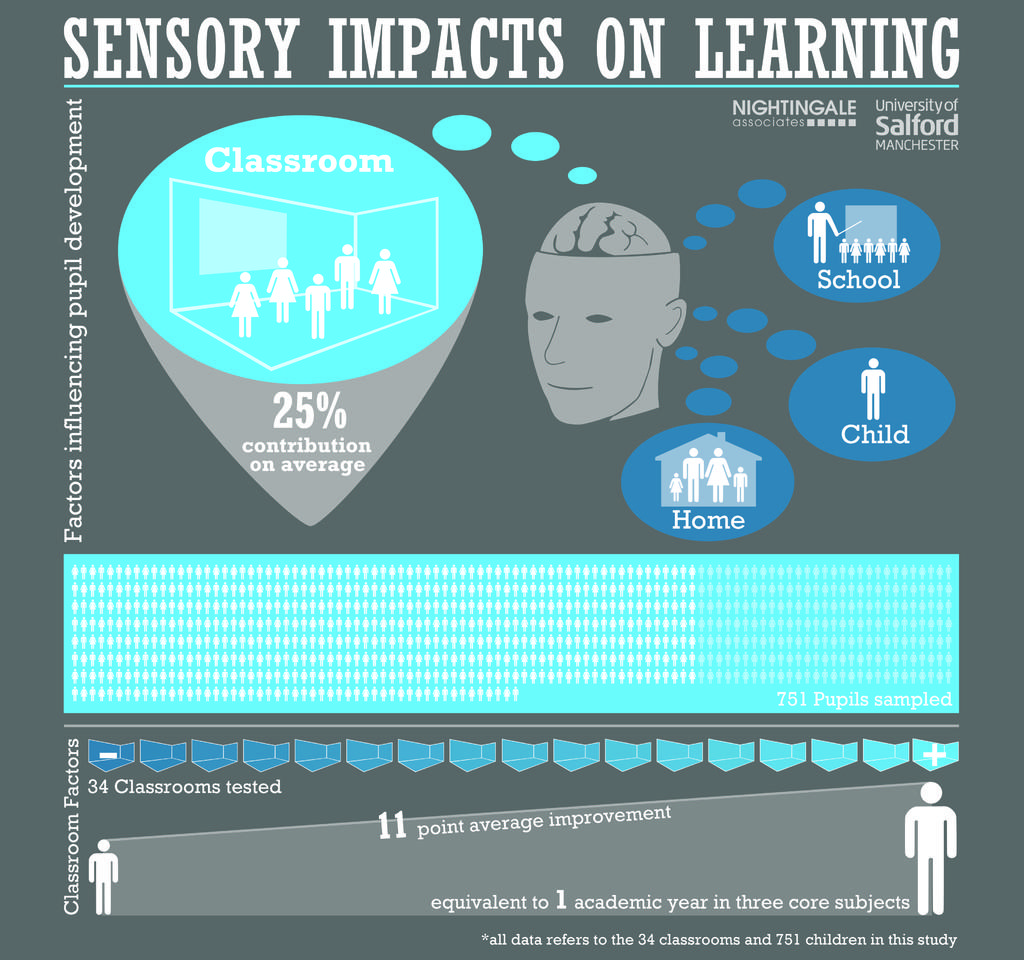What can be observed about the nature of the image? The image is edited. What types of visual elements are present in the image? There are pictures and text in the image. Where is the farm located in the image? There is no farm present in the image. How many balls are visible in the image? There is no ball present in the image. 